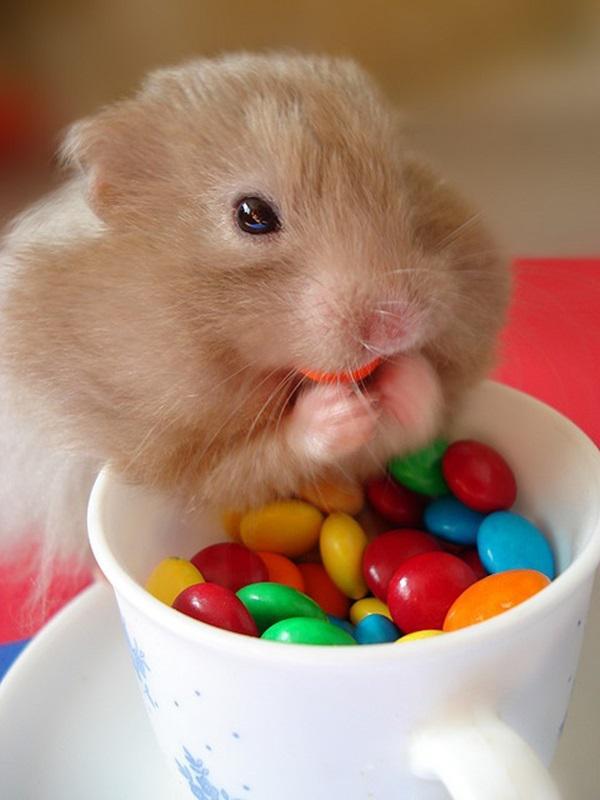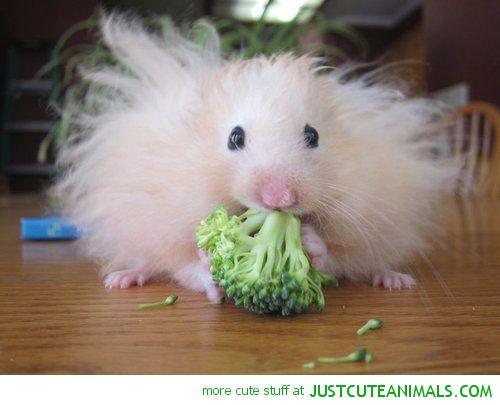The first image is the image on the left, the second image is the image on the right. For the images displayed, is the sentence "A hamster is holding a string." factually correct? Answer yes or no. No. 